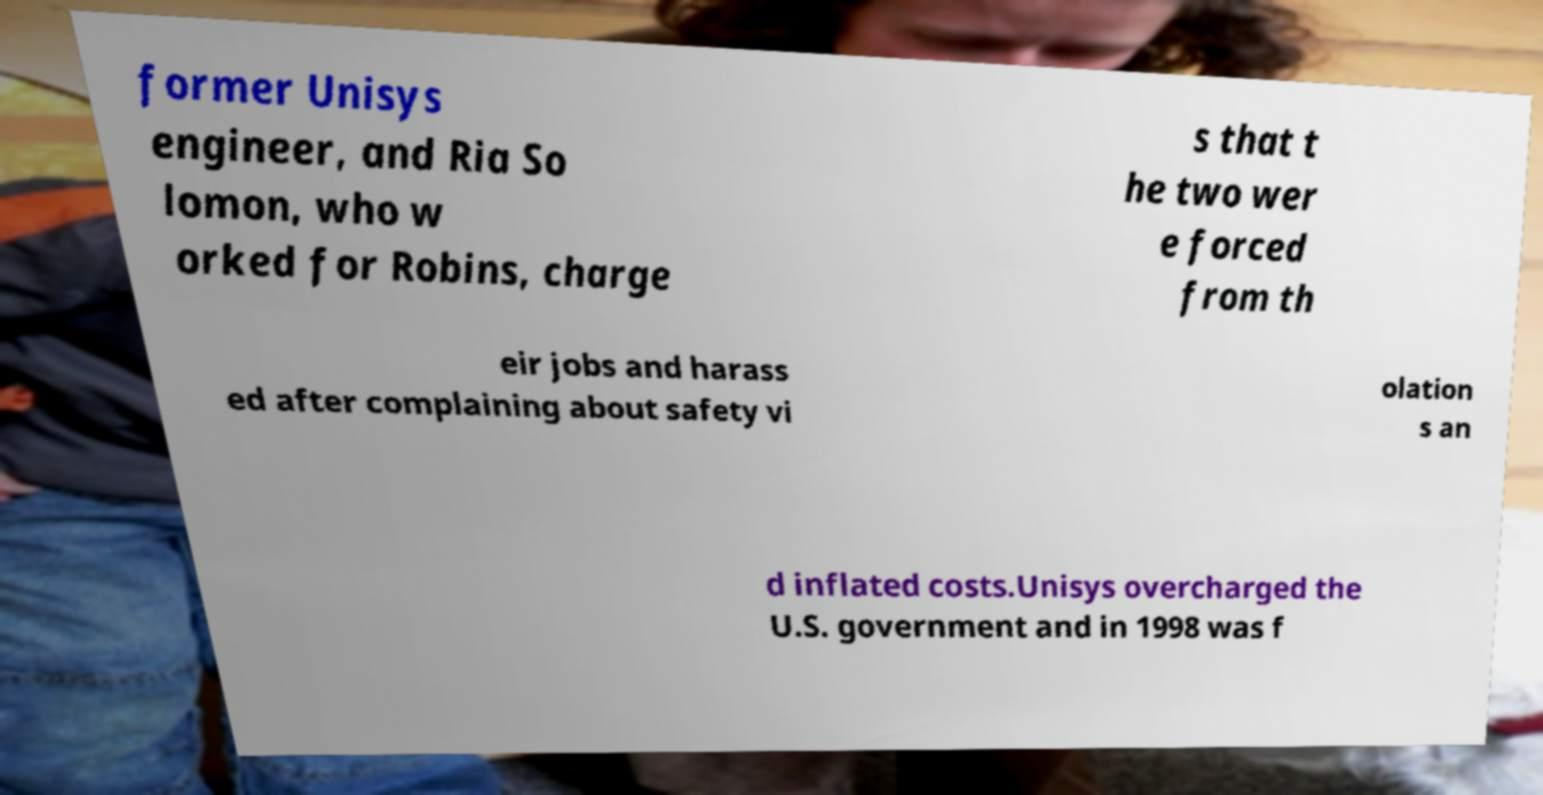What messages or text are displayed in this image? I need them in a readable, typed format. former Unisys engineer, and Ria So lomon, who w orked for Robins, charge s that t he two wer e forced from th eir jobs and harass ed after complaining about safety vi olation s an d inflated costs.Unisys overcharged the U.S. government and in 1998 was f 